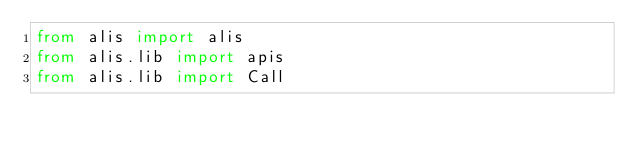<code> <loc_0><loc_0><loc_500><loc_500><_Python_>from alis import alis
from alis.lib import apis
from alis.lib import Call

</code> 